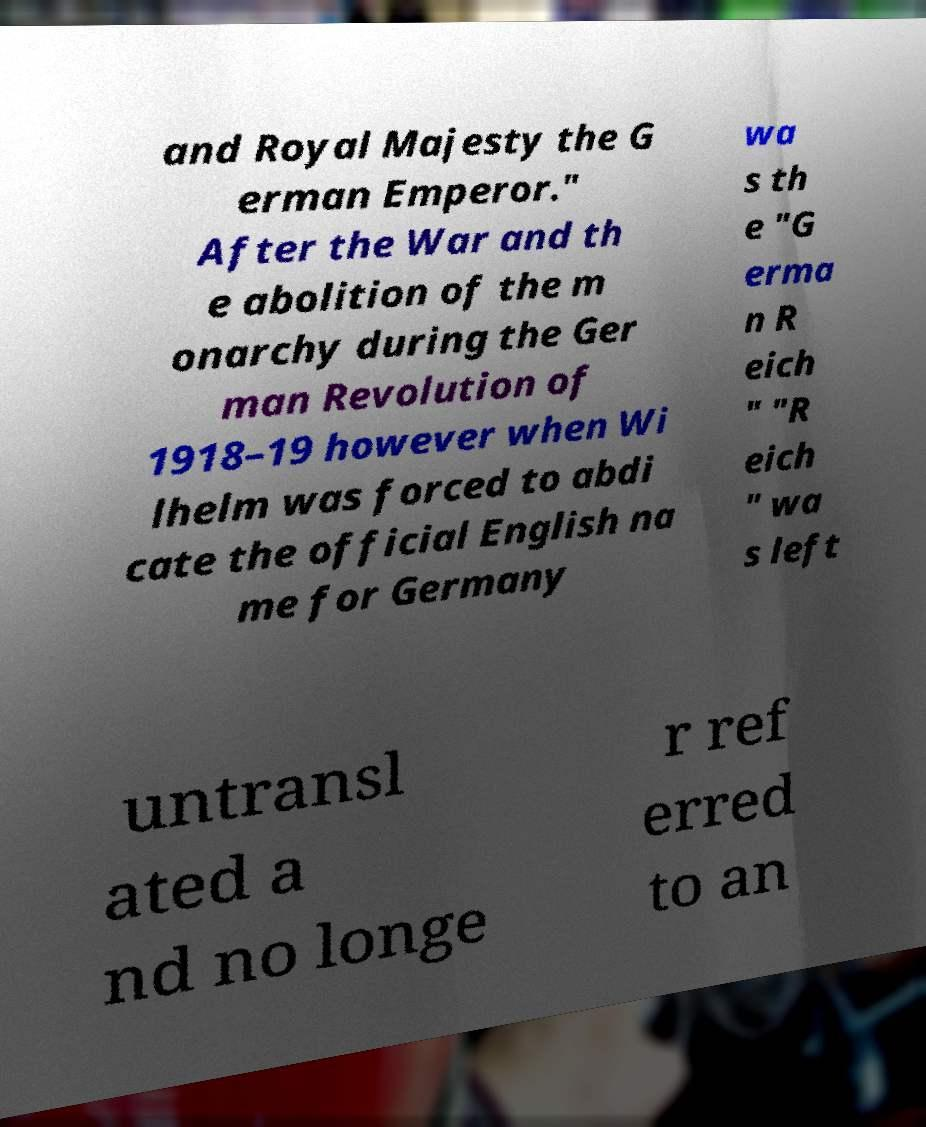Please identify and transcribe the text found in this image. and Royal Majesty the G erman Emperor." After the War and th e abolition of the m onarchy during the Ger man Revolution of 1918–19 however when Wi lhelm was forced to abdi cate the official English na me for Germany wa s th e "G erma n R eich " "R eich " wa s left untransl ated a nd no longe r ref erred to an 